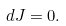Convert formula to latex. <formula><loc_0><loc_0><loc_500><loc_500>d J = 0 .</formula> 